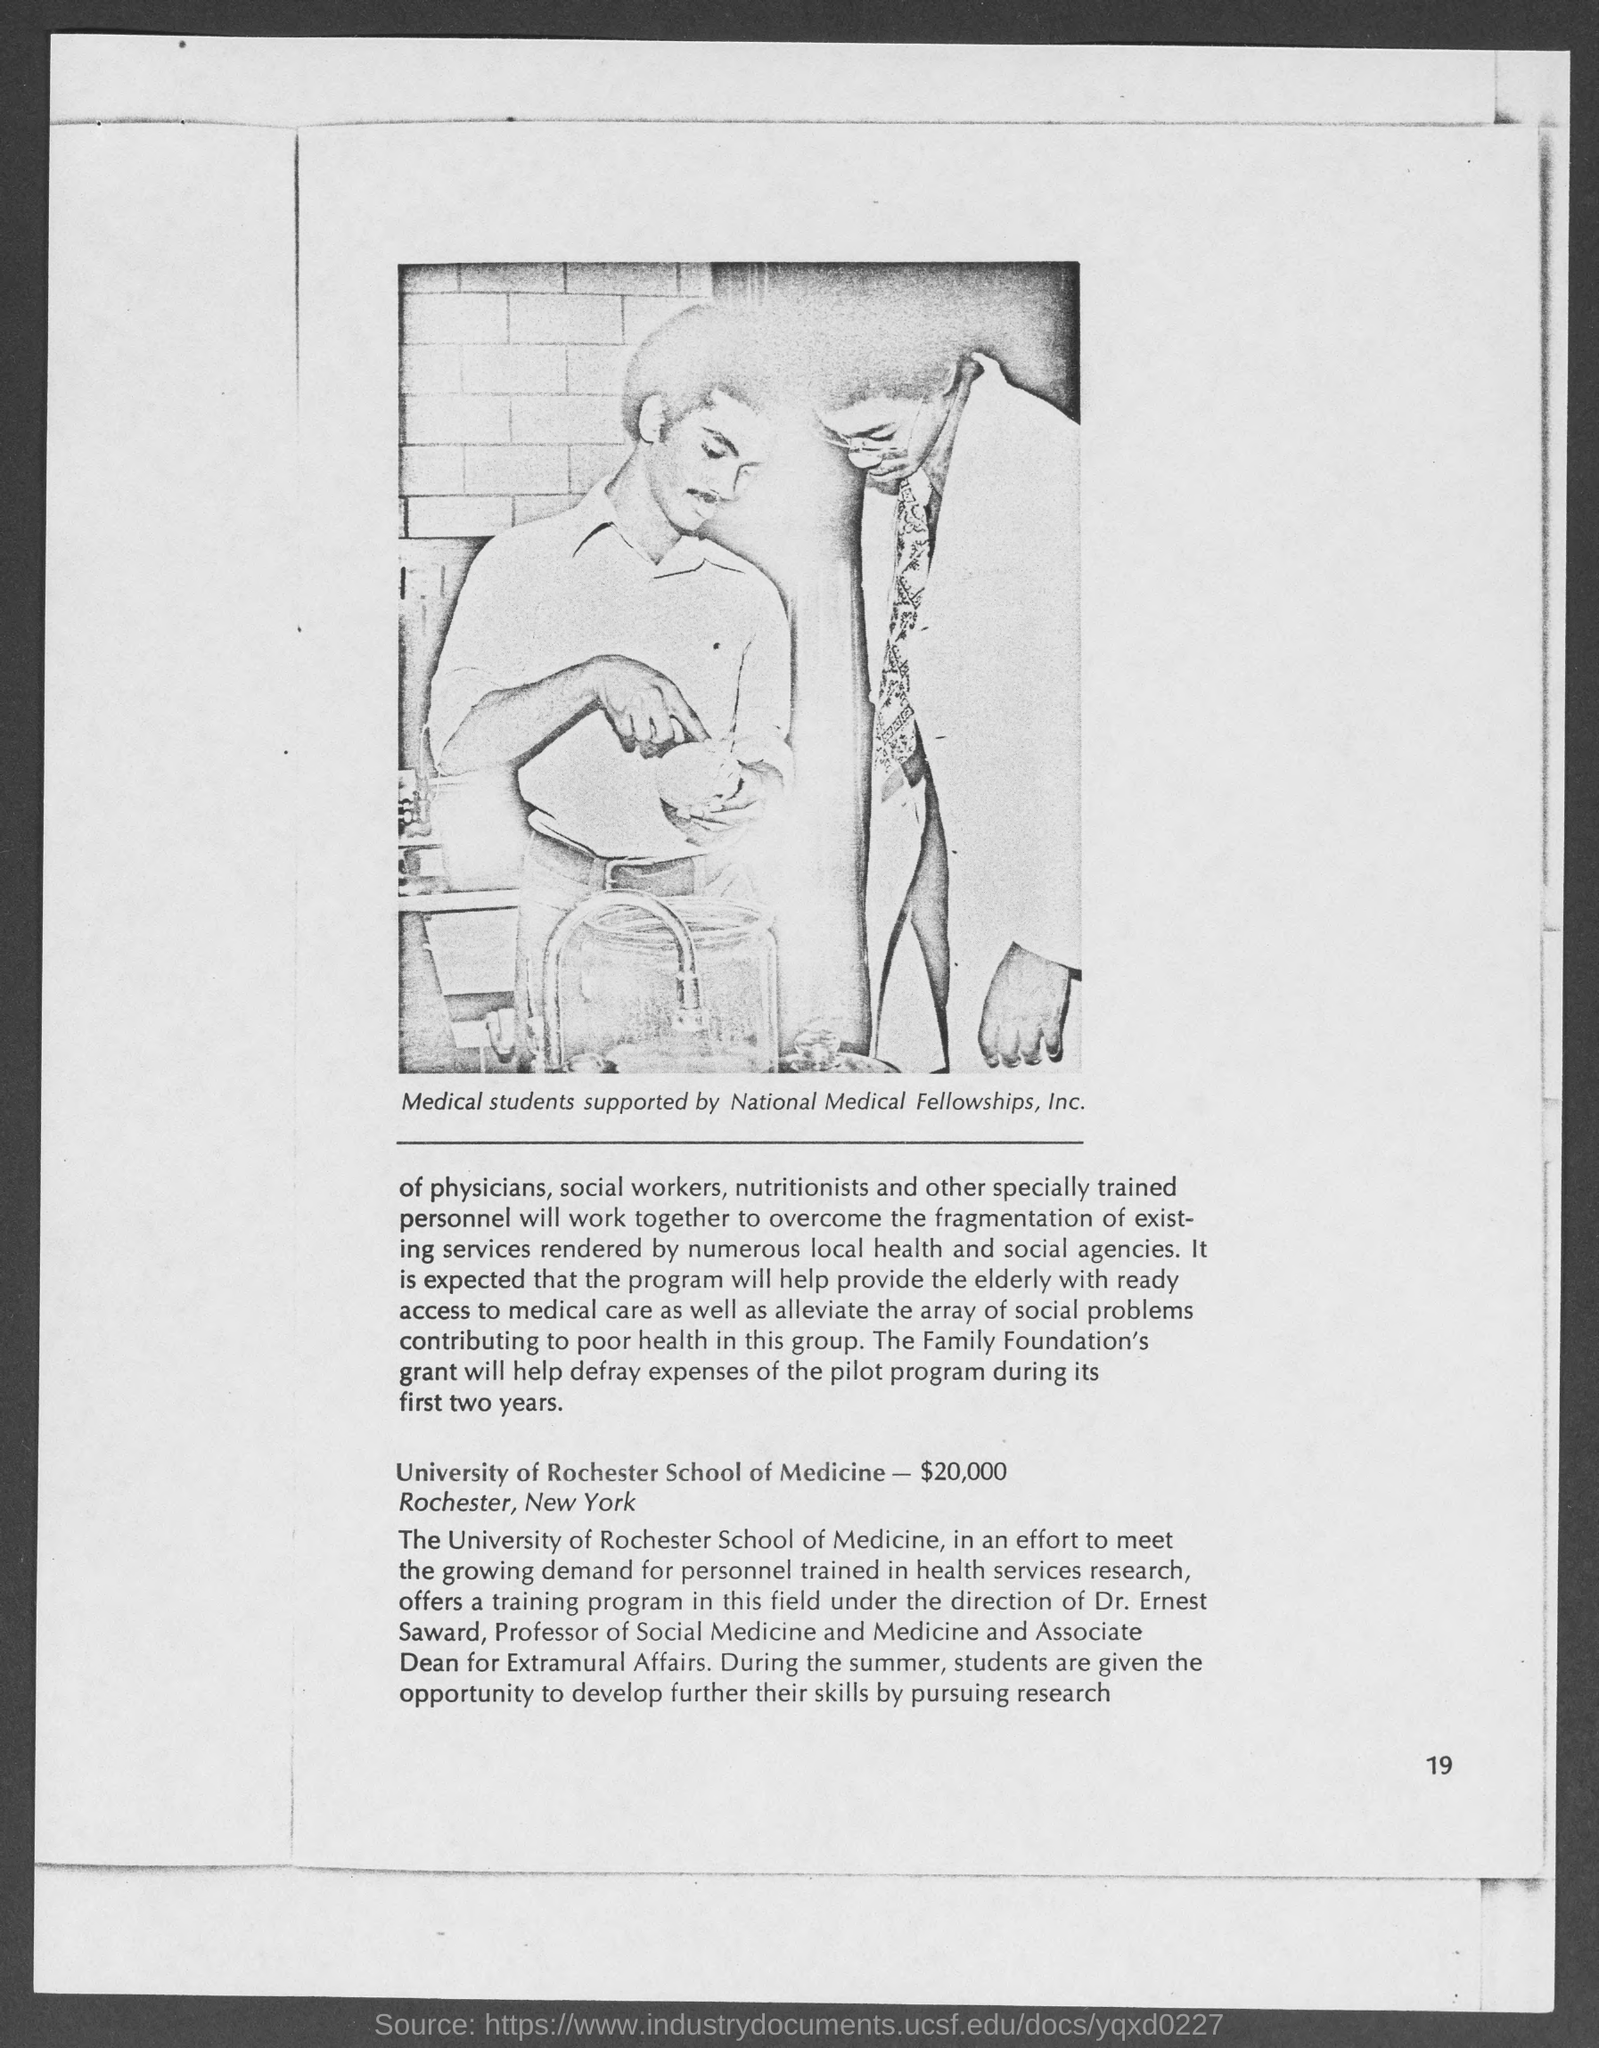Specify some key components in this picture. The University of Rochester School of Medicine is located in Rochester, New York. 